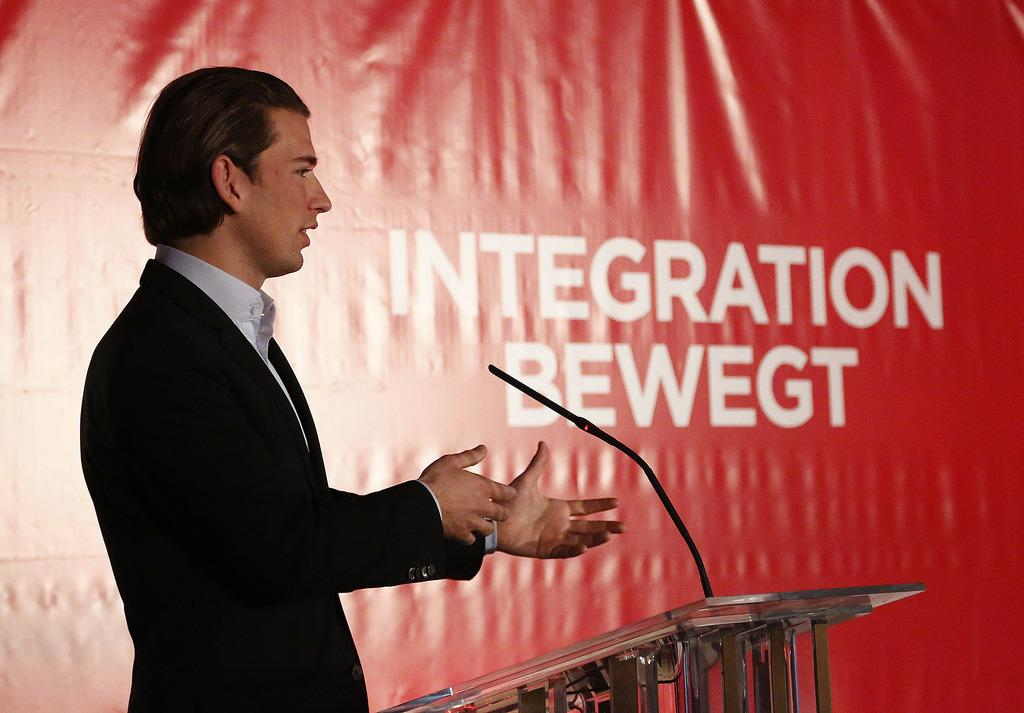Who is the main subject in the image? There is a man in the image. What is the man standing in front of? The man is standing in front of a glass podium. What is the man doing in the image? The man is speaking on a microphone. What is the man wearing in the image? The man is wearing a shirt and suit. What else can be seen in the image besides the man? There is a hoarding with text in the image. How many fish are swimming in the background of the image? There are no fish present in the image; it features a man standing in front of a glass podium and speaking on a microphone. What type of vest is the man wearing in the image? The man is not wearing a vest in the image; he is wearing a shirt and suit. 